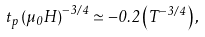Convert formula to latex. <formula><loc_0><loc_0><loc_500><loc_500>t _ { p } \left ( \mu _ { 0 } H \right ) ^ { - 3 / 4 } \simeq - 0 . 2 \left ( T ^ { - 3 / 4 } \right ) ,</formula> 